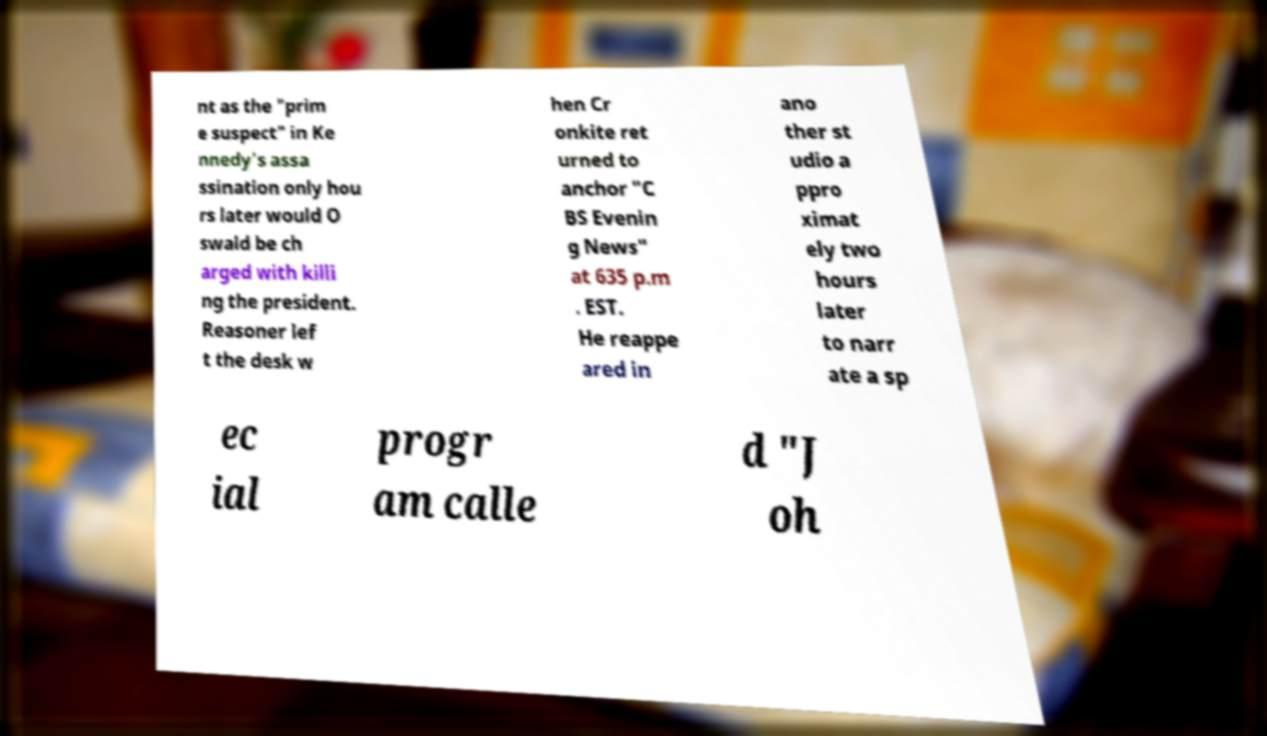What messages or text are displayed in this image? I need them in a readable, typed format. nt as the "prim e suspect" in Ke nnedy's assa ssination only hou rs later would O swald be ch arged with killi ng the president. Reasoner lef t the desk w hen Cr onkite ret urned to anchor "C BS Evenin g News" at 635 p.m . EST. He reappe ared in ano ther st udio a ppro ximat ely two hours later to narr ate a sp ec ial progr am calle d "J oh 